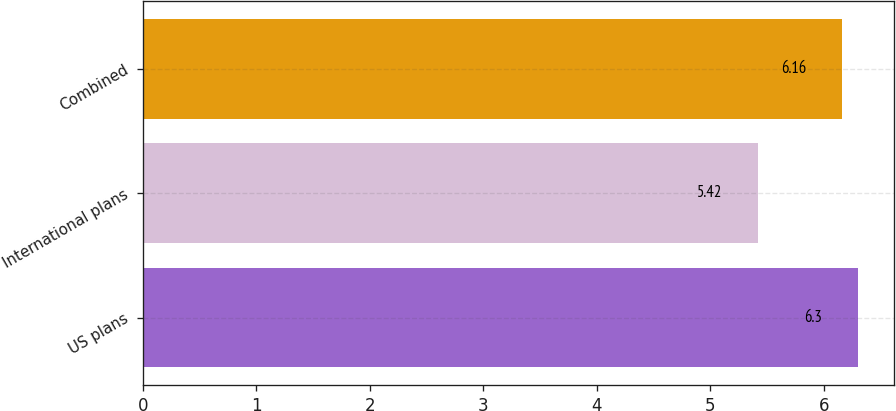<chart> <loc_0><loc_0><loc_500><loc_500><bar_chart><fcel>US plans<fcel>International plans<fcel>Combined<nl><fcel>6.3<fcel>5.42<fcel>6.16<nl></chart> 